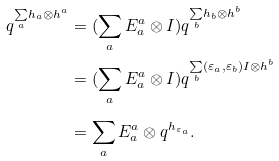Convert formula to latex. <formula><loc_0><loc_0><loc_500><loc_500>q ^ { \underset { a } { \sum } h _ { a } \otimes h ^ { a } } & = ( \sum _ { a } E ^ { a } _ { a } \otimes I ) q ^ { \underset { b } { \sum } h _ { b } \otimes h ^ { b } } \\ & = ( \sum _ { a } E ^ { a } _ { a } \otimes I ) q ^ { \underset { b } { \sum } ( \varepsilon _ { a } , \varepsilon _ { b } ) I \otimes h ^ { b } } \\ & = \sum _ { a } E ^ { a } _ { a } \otimes q ^ { h _ { \varepsilon _ { a } } } .</formula> 